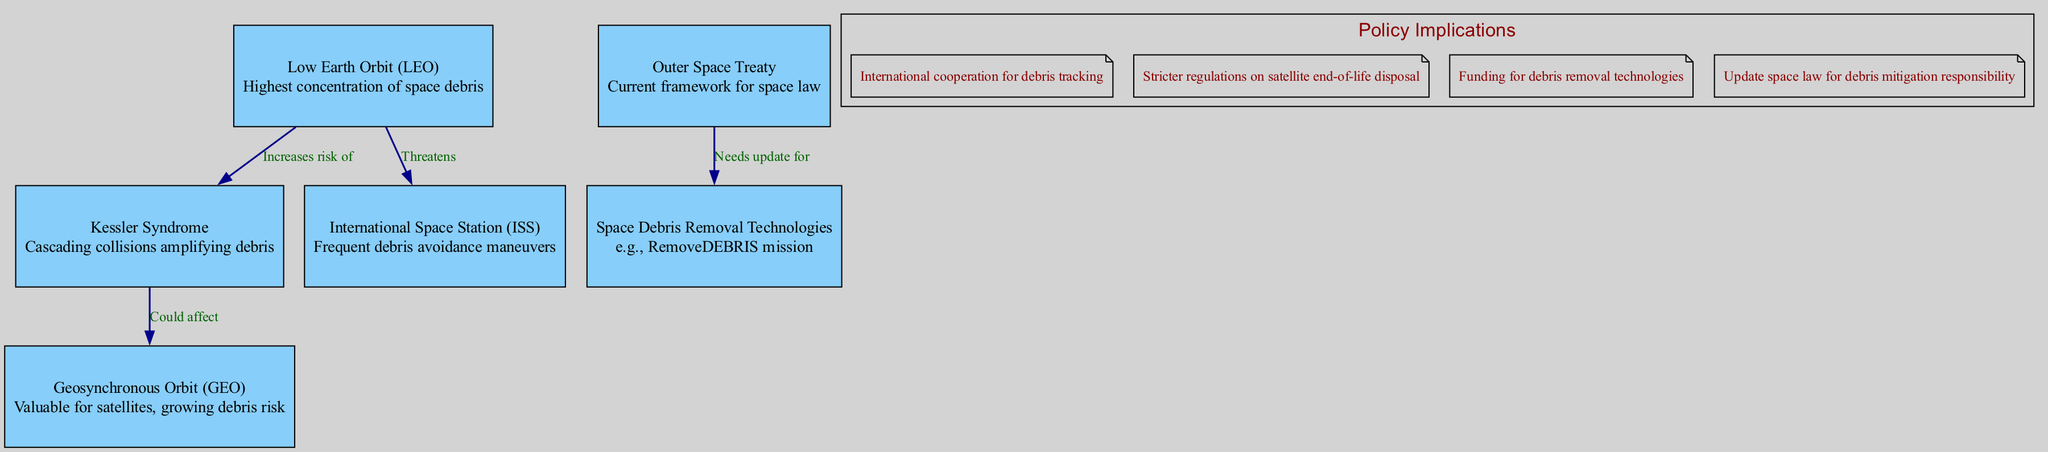What is the highest concentration of space debris? The node labeled "Low Earth Orbit (LEO)" indicates the highest concentration of space debris.
Answer: Low Earth Orbit (LEO) How many edges are in the diagram? Counting the edges in the diagram, there are four connections linking different nodes.
Answer: 4 What does "Kessler Syndrome" represent in the diagram? "Kessler Syndrome" is a node that describes cascading collisions amplifying debris, highlighting a significant concern for future space activities.
Answer: Cascading collisions amplifying debris Which node frequently performs debris avoidance maneuvers? The description of the "International Space Station (ISS)" indicates it frequently performs debris avoidance maneuvers to protect its operations.
Answer: International Space Station (ISS) What needs to be updated for debris mitigation responsibility? The edge from "Outer Space Treaty" to "Space Debris Removal Technologies" indicates that the current space law framework needs to be updated to incorporate debris mitigation responsibilities.
Answer: Update space law for debris mitigation responsibility How does Low Earth Orbit affect Kessler Syndrome? The edge labeled "Increases risk of" connects "Low Earth Orbit (LEO)" to "Kessler Syndrome", indicating that the debris in LEO significantly raises the risk of Kessler Syndrome occurring.
Answer: Increases risk of What are the implications of space debris for future space exploration? The policy implications listed in the diagram mention multiple strategies, including international cooperation for debris tracking and stricter regulations on satellite disposal to tackle the challenges posed by space debris.
Answer: International cooperation for debris tracking How could geosynchronous orbit be affected by Kessler Syndrome? The edge labeled "Could affect" connects "Kessler Syndrome" to "Geosynchronous Orbit (GEO)", suggesting that collisional debris events could pose risks to satellites in GEO.
Answer: Could affect What is an example of space debris removal technology? The node labeled "Space Debris Removal Technologies" lists the "RemoveDEBRIS mission" as a specific example of such technology aimed at mitigating the space debris issue.
Answer: RemoveDEBRIS mission 